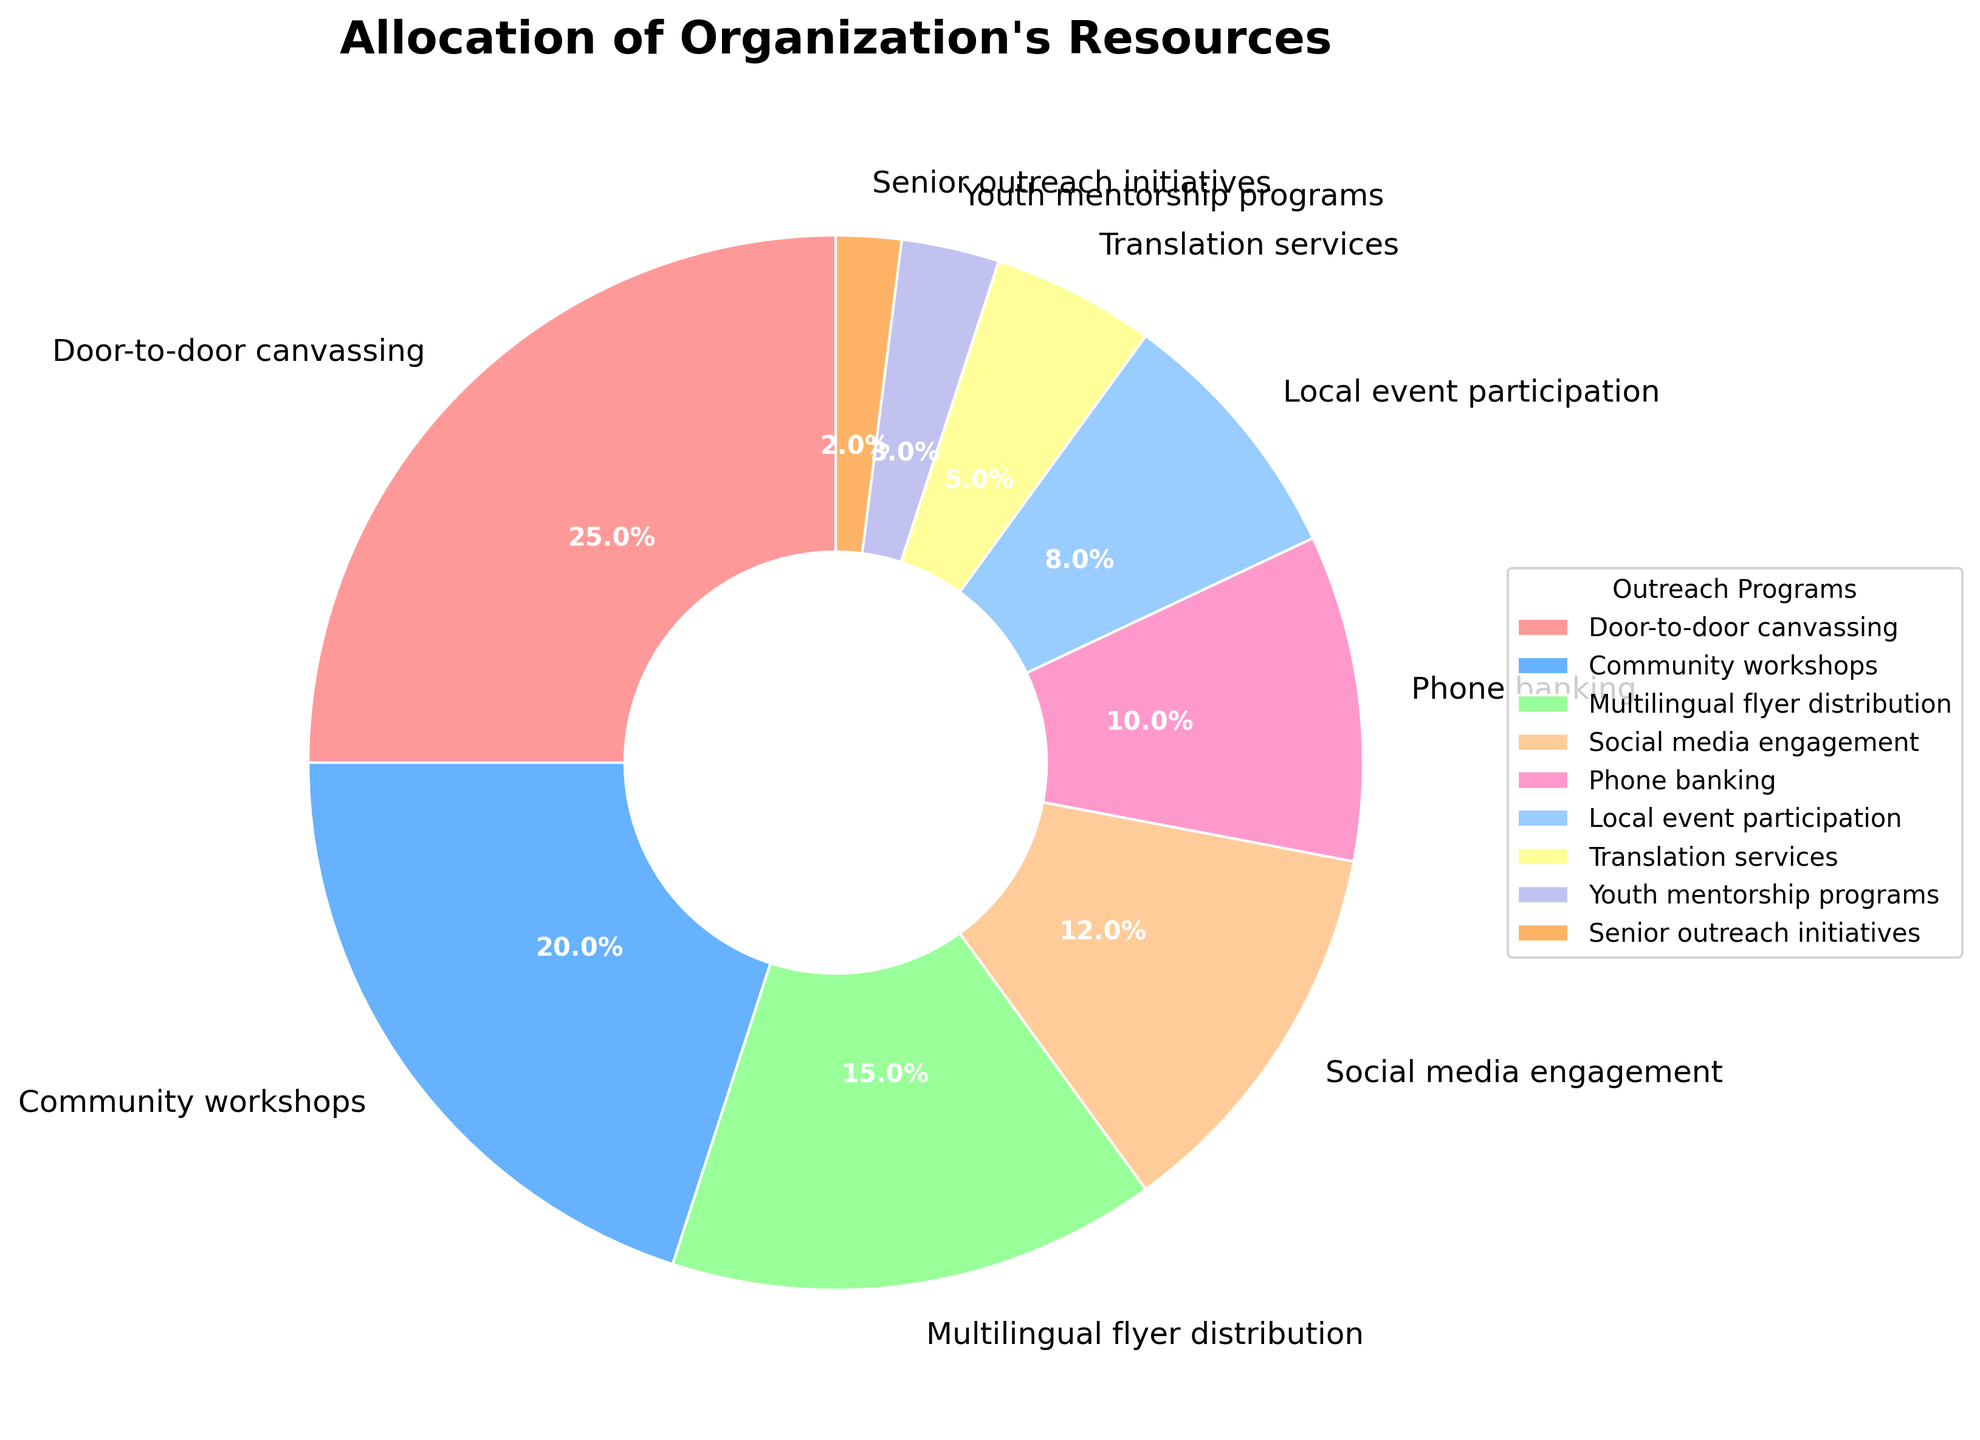What is the largest allocation of resources? The largest slice representing the highest percentage of allocation is the "Door-to-door canvassing" segment which has 25%.
Answer: Door-to-door canvassing Which program receives the least amount of resources? The smallest slice in the pie chart, indicating the lowest percentage allocation, is the "Senior outreach initiatives" program with 2%.
Answer: Senior outreach initiatives How much more percentage is allocated to "Community workshops" compared to "Phone banking"? The allocation for "Community workshops" is 20%, and for "Phone banking" it's 10%. Subtract 10% from 20% to find the difference.
Answer: 10% What is the combined allocation for "Social media engagement" and "Multilingual flyer distribution"? The percentages for "Social media engagement" and "Multilingual flyer distribution" are 12% and 15% respectively. Add these two together: 12% + 15% = 27%.
Answer: 27% Are "Translation services" allocated more resources than "Youth mentorship programs"? The "Translation services" slice is larger than the "Youth mentorship programs" slice, indicating 5% and 3% allocations respectively.
Answer: Yes Which programs together account for more than half of the resources? Adding the top allocations: Door-to-door canvassing (25%), Community workshops (20%), Multilingual flyer distribution (15%), and Social media engagement (12%). The total is 25% + 20% + 15% + 12% = 72%, which is more than half.
Answer: Door-to-door canvassing, Community workshops, Multilingual flyer distribution, Social media engagement What is the difference in resource allocation between "Local event participation" and "Translation services"? "Local event participation" is allocated 8%, and "Translation services" is allocated 5%. Subtract the smaller percentage from the larger one: 8% - 5% = 3%.
Answer: 3% Which color represents the "Senior outreach initiatives"? By matching the symbol from the pie chart legend to the slice, the color representing "Senior outreach initiatives" is usually marked, in this case likely a visually distinct color such as the last in the sequence (darker shade).
Answer: (Color of the slice as indicated in the chart, example: dark purple) How much more resources are allocated to "Door-to-door canvassing" than "Local event participation"? "Door-to-door canvassing" is allocated 25%, whereas "Local event participation" is allocated 8%. Subtract the lower value from the higher one: 25% - 8% = 17%.
Answer: 17% Is "Social media engagement" allocated more resources than "Translation services" and "Youth mentorship programs" combined? "Social media engagement" is allocated 12%. "Translation services" and "Youth mentorship programs" together have 5% + 3% = 8%. Since 12% is greater than 8%, the answer is yes.
Answer: Yes 